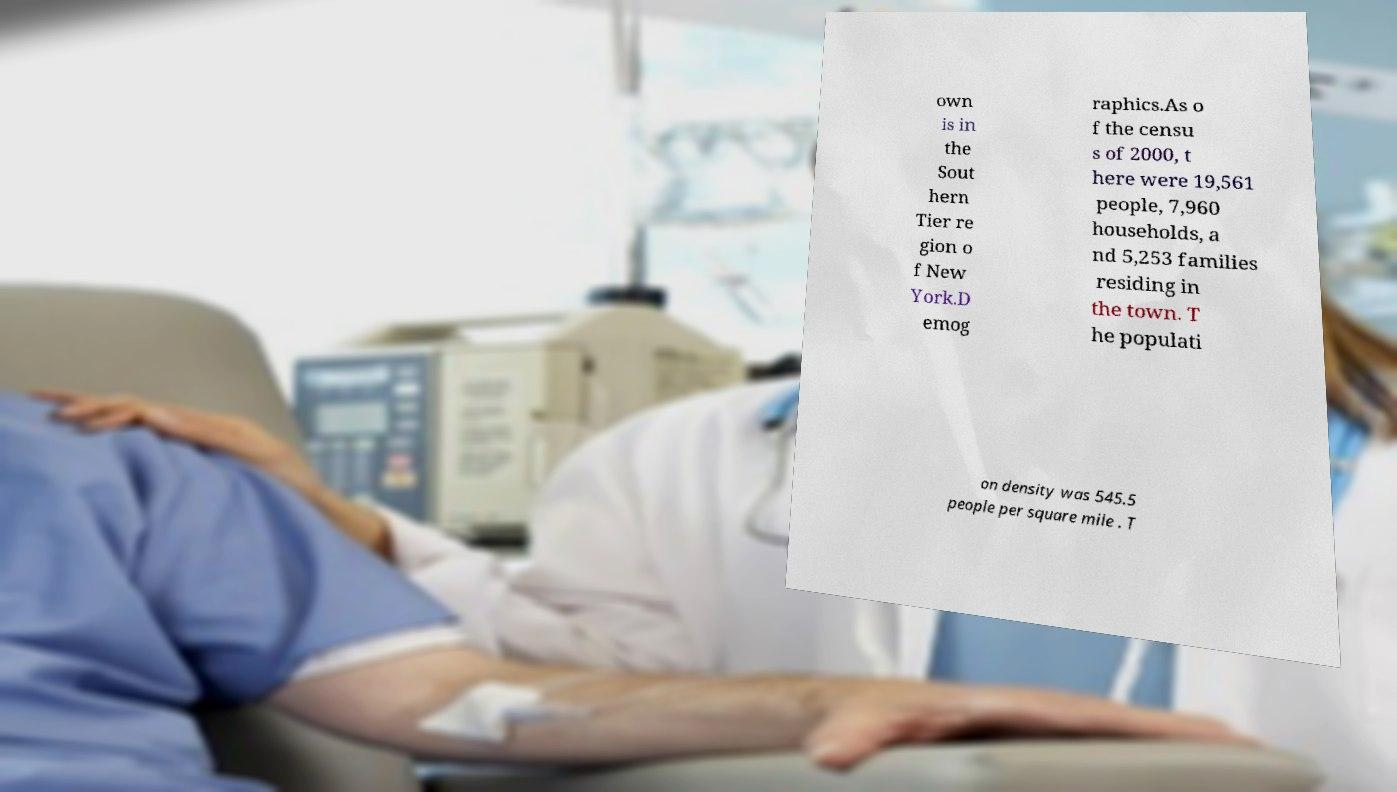Please identify and transcribe the text found in this image. own is in the Sout hern Tier re gion o f New York.D emog raphics.As o f the censu s of 2000, t here were 19,561 people, 7,960 households, a nd 5,253 families residing in the town. T he populati on density was 545.5 people per square mile . T 